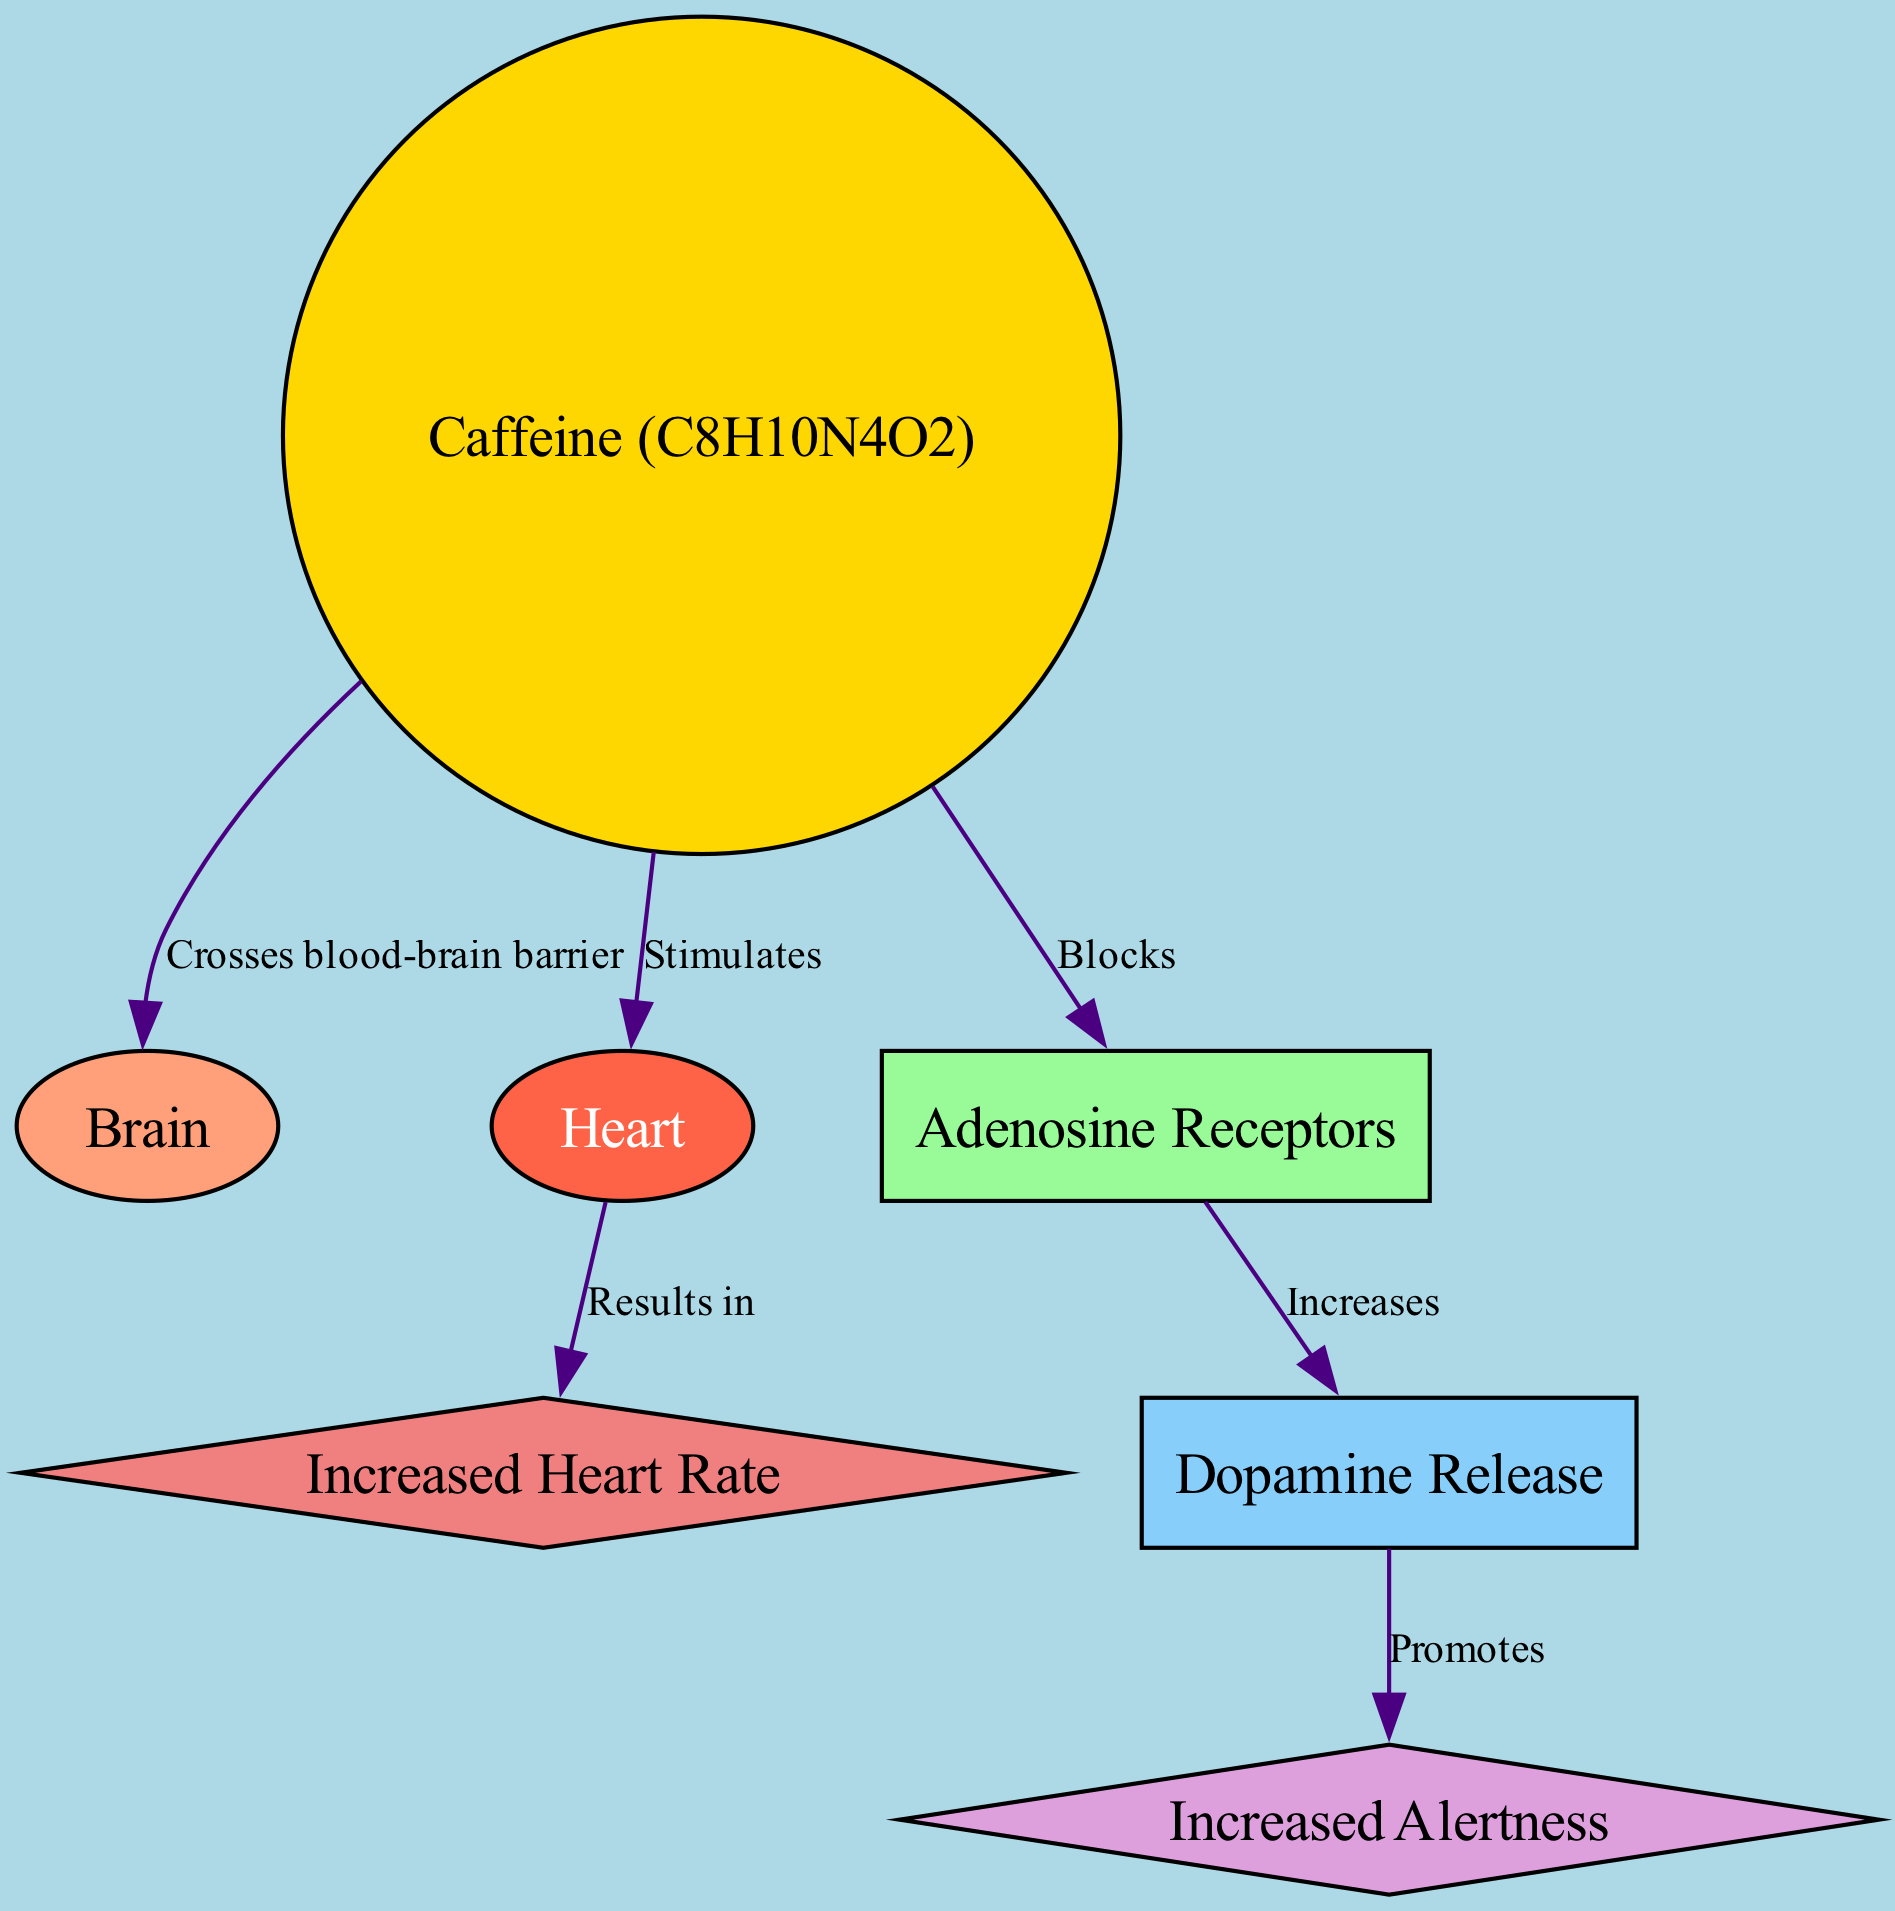What is the molecular formula of caffeine? The diagram specifies the label of the caffeine node, which includes its molecular formula as "C8H10N4O2."
Answer: C8H10N4O2 How many nodes are there in the diagram? By counting the nodes listed in the data, we identify seven distinct nodes: caffeine, brain, heart, adenosine, dopamine, alertness, and heart rate.
Answer: 7 What physiological effect results from caffeine's stimulation of the heart? The diagram connects the heart node to heart rate, indicating that the stimulation of the heart results in an increased heart rate.
Answer: Increased Heart Rate Which node does caffeine block according to the diagram? The edge from caffeine indicates it blocks the adenosine receptors, which is explicitly stated in the relationships presented.
Answer: Adenosine Receptors What does dopamine promote according to the diagram? The diagram shows a flow from dopamine to alertness, indicating that dopamine promotes increased alertness in the body.
Answer: Increased Alertness What is the relationship between caffeine and the brain? The edge from caffeine to brain indicates that caffeine crosses the blood-brain barrier, signifying its direct effect on the brain after consumption.
Answer: Crosses blood-brain barrier If caffeine blocks adenosine receptors, what is the subsequent effect on dopamine according to the diagram? The diagram demonstrates that by blocking adenosine, caffeine leads to an increase in dopamine release, establishing a chain of events that follows this interaction.
Answer: Increases What color represents the caffeine node in the diagram? According to the node styles defined in the diagram, the caffeine node is represented in gold, as indicated by its fill color "#FFD700."
Answer: Gold 